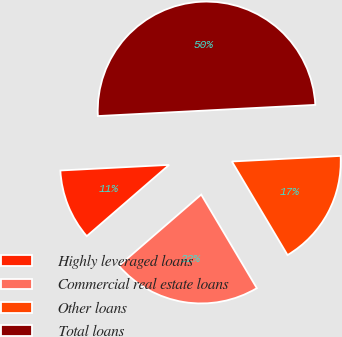Convert chart. <chart><loc_0><loc_0><loc_500><loc_500><pie_chart><fcel>Highly leveraged loans<fcel>Commercial real estate loans<fcel>Other loans<fcel>Total loans<nl><fcel>10.54%<fcel>22.18%<fcel>17.28%<fcel>50.0%<nl></chart> 